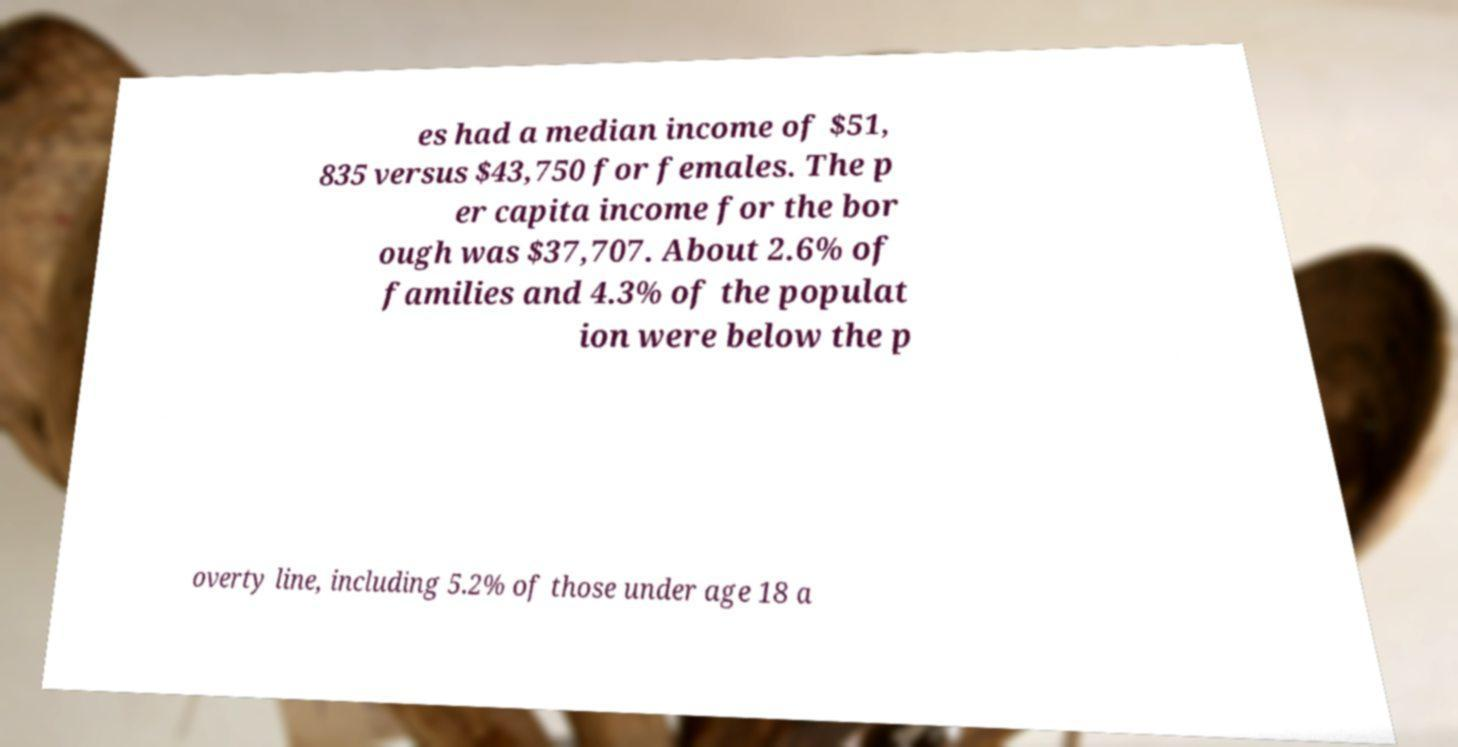Could you extract and type out the text from this image? es had a median income of $51, 835 versus $43,750 for females. The p er capita income for the bor ough was $37,707. About 2.6% of families and 4.3% of the populat ion were below the p overty line, including 5.2% of those under age 18 a 